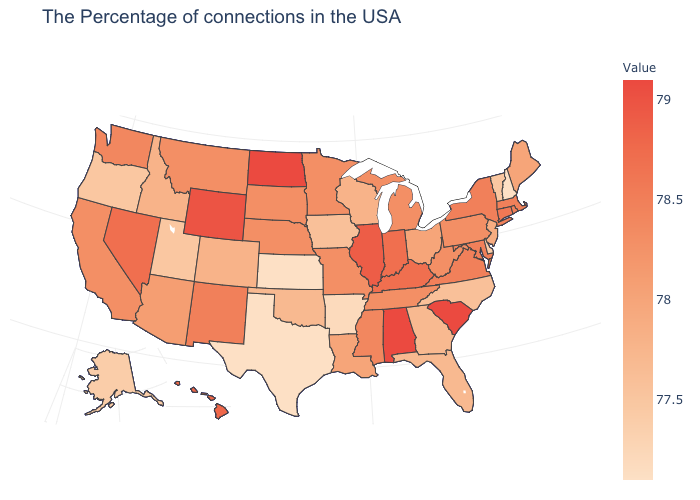Does Alaska have the lowest value in the West?
Keep it brief. Yes. Among the states that border California , which have the highest value?
Concise answer only. Nevada. Does Delaware have a lower value than Kansas?
Be succinct. No. Which states have the lowest value in the USA?
Write a very short answer. New Hampshire, Kansas, Texas. Among the states that border Massachusetts , which have the highest value?
Keep it brief. Connecticut. Does West Virginia have a higher value than Oklahoma?
Answer briefly. Yes. Among the states that border Arkansas , which have the lowest value?
Be succinct. Texas. 